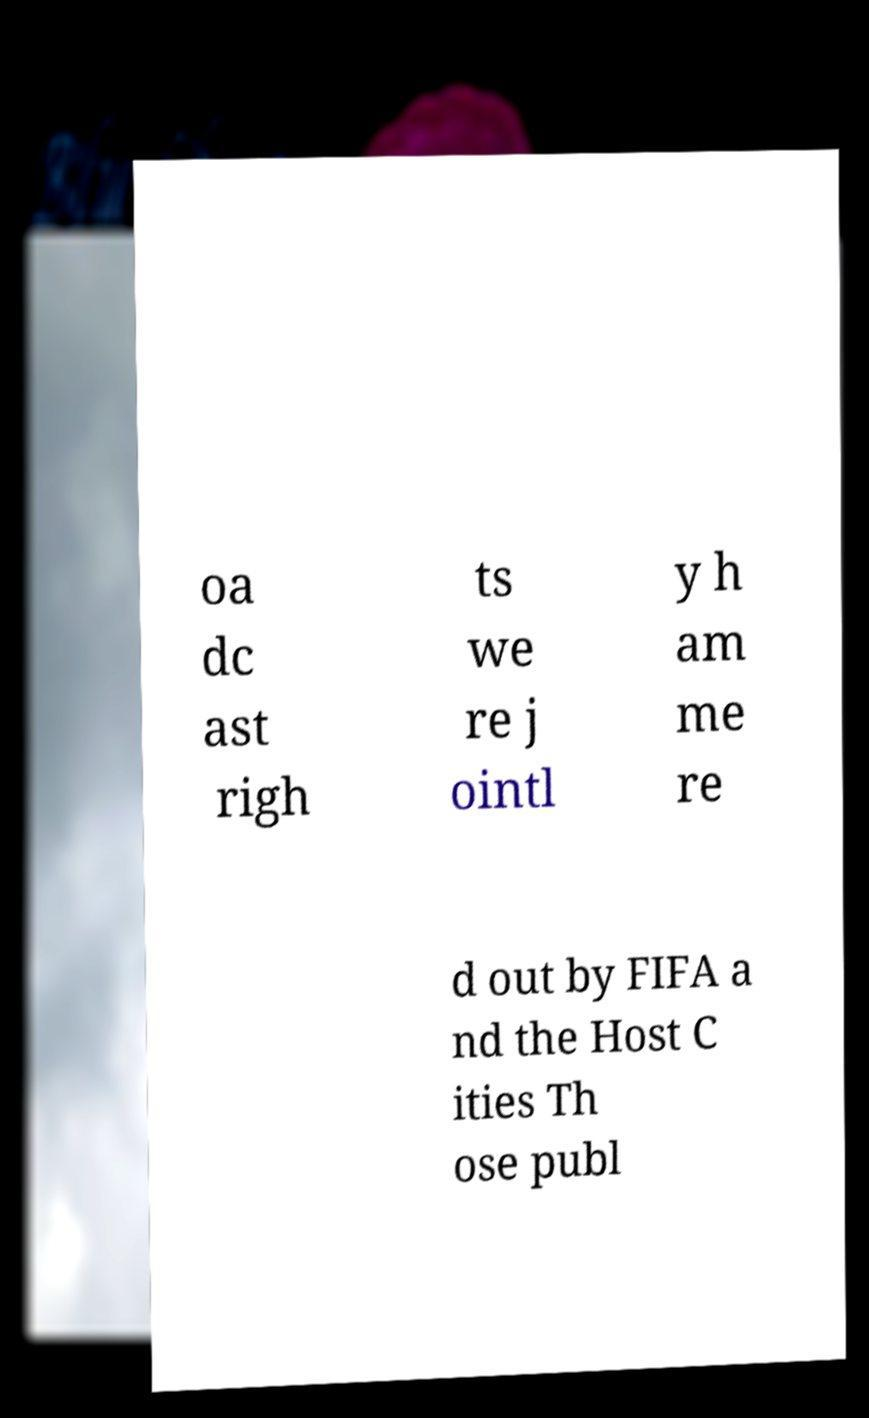Could you extract and type out the text from this image? oa dc ast righ ts we re j ointl y h am me re d out by FIFA a nd the Host C ities Th ose publ 